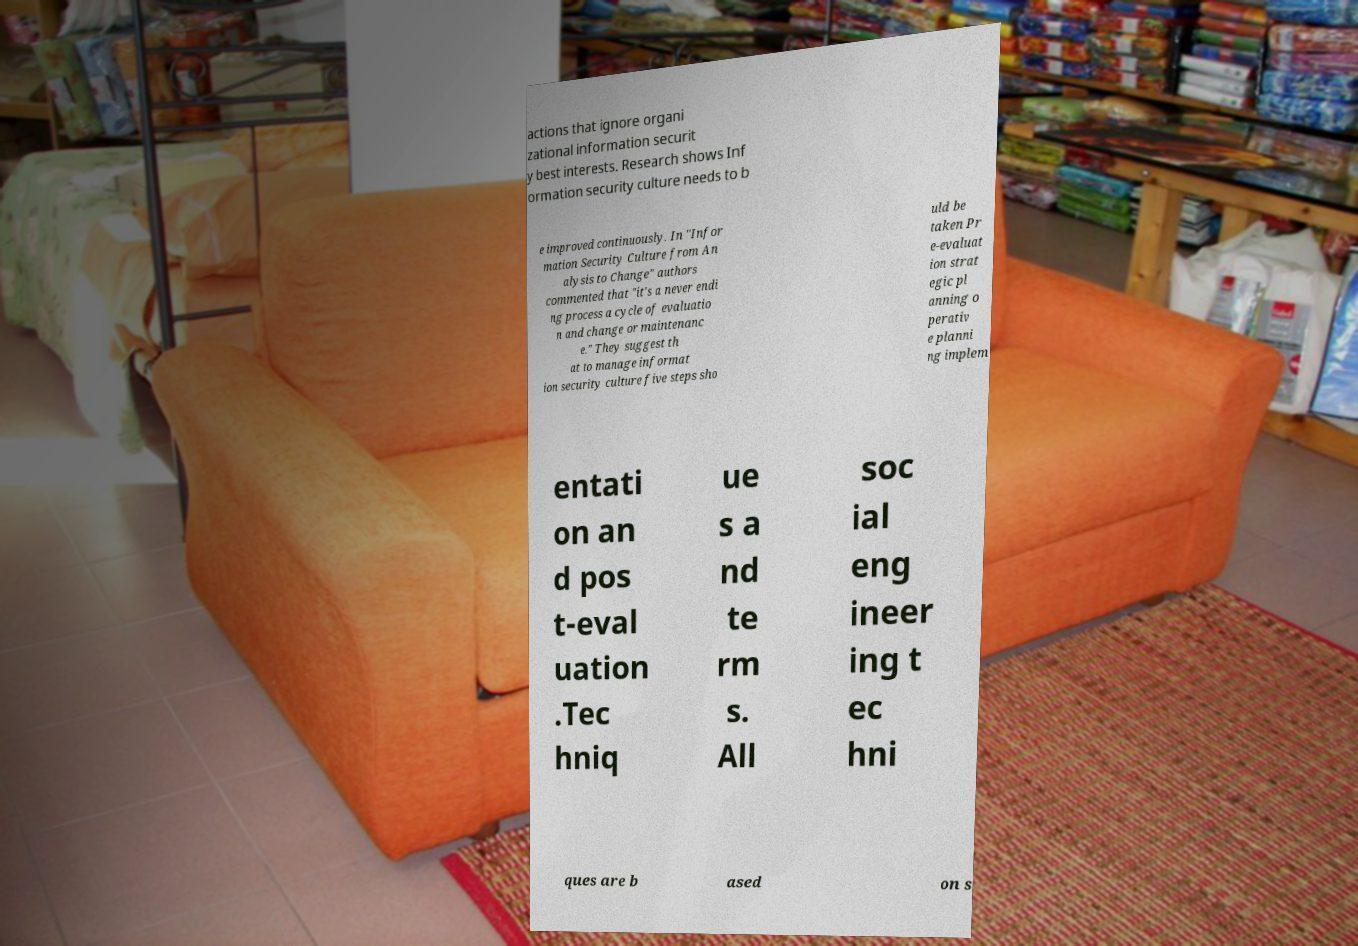Please read and relay the text visible in this image. What does it say? actions that ignore organi zational information securit y best interests. Research shows Inf ormation security culture needs to b e improved continuously. In "Infor mation Security Culture from An alysis to Change" authors commented that "it's a never endi ng process a cycle of evaluatio n and change or maintenanc e." They suggest th at to manage informat ion security culture five steps sho uld be taken Pr e-evaluat ion strat egic pl anning o perativ e planni ng implem entati on an d pos t-eval uation .Tec hniq ue s a nd te rm s. All soc ial eng ineer ing t ec hni ques are b ased on s 